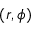Convert formula to latex. <formula><loc_0><loc_0><loc_500><loc_500>( r , \phi )</formula> 